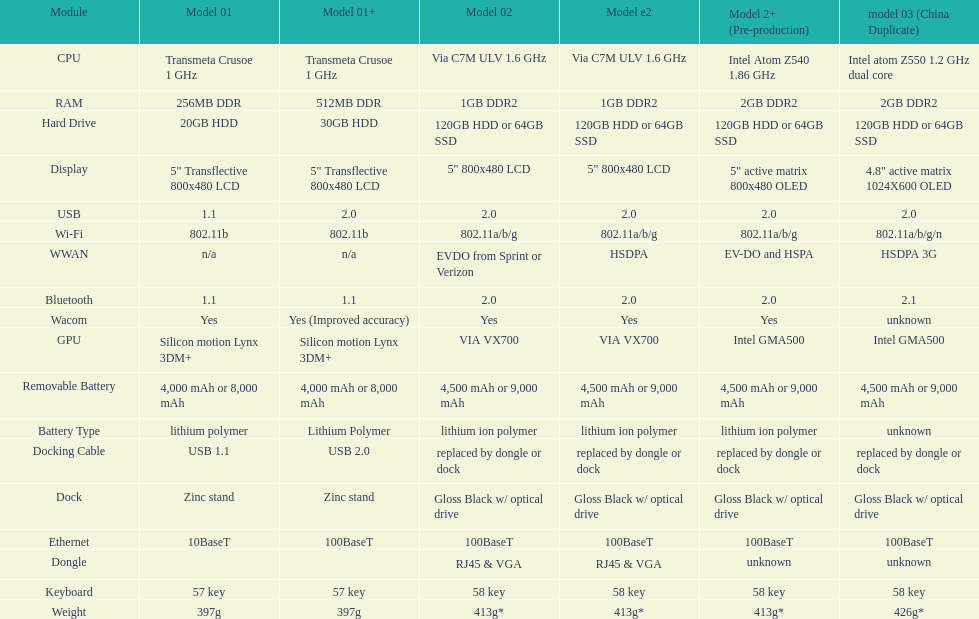Parse the table in full. {'header': ['Module', 'Model 01', 'Model 01+', 'Model 02', 'Model e2', 'Model 2+ (Pre-production)', 'model 03 (China Duplicate)'], 'rows': [['CPU', 'Transmeta Crusoe 1\xa0GHz', 'Transmeta Crusoe 1\xa0GHz', 'Via C7M ULV 1.6\xa0GHz', 'Via C7M ULV 1.6\xa0GHz', 'Intel Atom Z540 1.86\xa0GHz', 'Intel atom Z550 1.2\xa0GHz dual core'], ['RAM', '256MB DDR', '512MB DDR', '1GB DDR2', '1GB DDR2', '2GB DDR2', '2GB DDR2'], ['Hard Drive', '20GB HDD', '30GB HDD', '120GB HDD or 64GB SSD', '120GB HDD or 64GB SSD', '120GB HDD or 64GB SSD', '120GB HDD or 64GB SSD'], ['Display', '5" Transflective 800x480 LCD', '5" Transflective 800x480 LCD', '5" 800x480 LCD', '5" 800x480 LCD', '5" active matrix 800x480 OLED', '4.8" active matrix 1024X600 OLED'], ['USB', '1.1', '2.0', '2.0', '2.0', '2.0', '2.0'], ['Wi-Fi', '802.11b', '802.11b', '802.11a/b/g', '802.11a/b/g', '802.11a/b/g', '802.11a/b/g/n'], ['WWAN', 'n/a', 'n/a', 'EVDO from Sprint or Verizon', 'HSDPA', 'EV-DO and HSPA', 'HSDPA 3G'], ['Bluetooth', '1.1', '1.1', '2.0', '2.0', '2.0', '2.1'], ['Wacom', 'Yes', 'Yes (Improved accuracy)', 'Yes', 'Yes', 'Yes', 'unknown'], ['GPU', 'Silicon motion Lynx 3DM+', 'Silicon motion Lynx 3DM+', 'VIA VX700', 'VIA VX700', 'Intel GMA500', 'Intel GMA500'], ['Removable Battery', '4,000 mAh or 8,000 mAh', '4,000 mAh or 8,000 mAh', '4,500 mAh or 9,000 mAh', '4,500 mAh or 9,000 mAh', '4,500 mAh or 9,000 mAh', '4,500 mAh or 9,000 mAh'], ['Battery Type', 'lithium polymer', 'Lithium Polymer', 'lithium ion polymer', 'lithium ion polymer', 'lithium ion polymer', 'unknown'], ['Docking Cable', 'USB 1.1', 'USB 2.0', 'replaced by dongle or dock', 'replaced by dongle or dock', 'replaced by dongle or dock', 'replaced by dongle or dock'], ['Dock', 'Zinc stand', 'Zinc stand', 'Gloss Black w/ optical drive', 'Gloss Black w/ optical drive', 'Gloss Black w/ optical drive', 'Gloss Black w/ optical drive'], ['Ethernet', '10BaseT', '100BaseT', '100BaseT', '100BaseT', '100BaseT', '100BaseT'], ['Dongle', '', '', 'RJ45 & VGA', 'RJ45 & VGA', 'unknown', 'unknown'], ['Keyboard', '57 key', '57 key', '58 key', '58 key', '58 key', '58 key'], ['Weight', '397g', '397g', '413g*', '413g*', '413g*', '426g*']]} How much more weight does the model 3 have over model 1? 29g. 